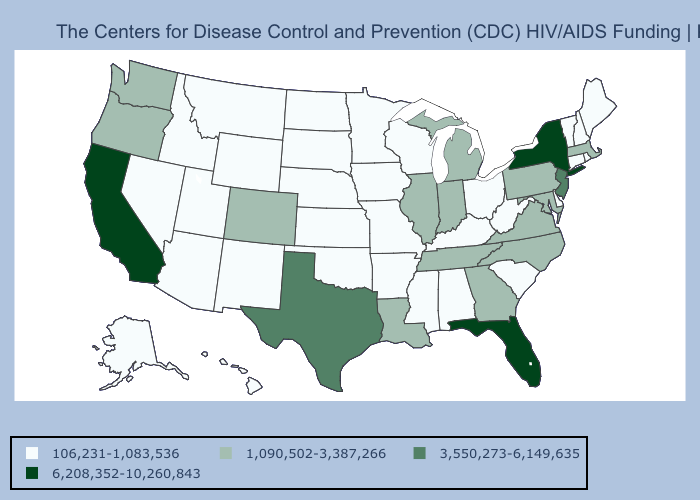Does the first symbol in the legend represent the smallest category?
Short answer required. Yes. What is the highest value in states that border South Dakota?
Concise answer only. 106,231-1,083,536. What is the value of Nebraska?
Write a very short answer. 106,231-1,083,536. Among the states that border West Virginia , does Maryland have the lowest value?
Concise answer only. No. Does Connecticut have the lowest value in the Northeast?
Answer briefly. Yes. What is the highest value in the West ?
Write a very short answer. 6,208,352-10,260,843. Does Michigan have a higher value than Delaware?
Be succinct. Yes. What is the lowest value in states that border Ohio?
Concise answer only. 106,231-1,083,536. Which states have the lowest value in the USA?
Short answer required. Alabama, Alaska, Arizona, Arkansas, Connecticut, Delaware, Hawaii, Idaho, Iowa, Kansas, Kentucky, Maine, Minnesota, Mississippi, Missouri, Montana, Nebraska, Nevada, New Hampshire, New Mexico, North Dakota, Ohio, Oklahoma, Rhode Island, South Carolina, South Dakota, Utah, Vermont, West Virginia, Wisconsin, Wyoming. Name the states that have a value in the range 3,550,273-6,149,635?
Answer briefly. New Jersey, Texas. Is the legend a continuous bar?
Short answer required. No. Among the states that border South Carolina , which have the lowest value?
Be succinct. Georgia, North Carolina. Does New Hampshire have the same value as Michigan?
Answer briefly. No. Does California have the highest value in the USA?
Be succinct. Yes. 